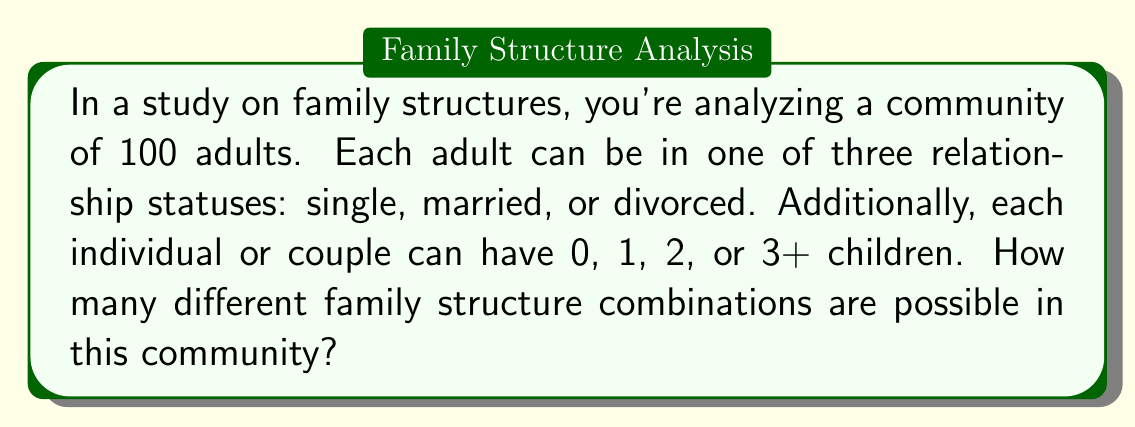Show me your answer to this math problem. Let's approach this step-by-step:

1) First, we need to consider the relationship status options:
   - Single
   - Married
   - Divorced

2) Next, we consider the number of children options:
   - 0 children
   - 1 child
   - 2 children
   - 3+ children

3) For single and divorced individuals, we can directly combine their relationship status with the child options:
   $3 \times 4 = 12$ combinations

4) For married couples, we need to consider that they share the same number of children:
   $1 \times 4 = 4$ combinations

5) Total number of possible family structures for one individual or couple:
   $12 + 4 = 16$ combinations

6) Now, we need to consider how many ways these structures can be distributed among 100 adults. This is a problem of combinations with repetition.

7) The formula for combinations with repetition is:
   $$\binom{n+r-1}{r-1}$$
   where $n$ is the number of types to choose from, and $r$ is the number of items being chosen.

8) In our case, $n = 16$ (number of family structure types) and $r = 100$ (number of adults).

9) Plugging into the formula:
   $$\binom{16+100-1}{16-1} = \binom{115}{15}$$

10) This can be calculated as:
    $$\frac{115!}{15!(115-15)!} = \frac{115!}{15!100!}$$

11) The result of this calculation is a very large number, approximately $2.98 \times 10^{18}$.
Answer: $\binom{115}{15} \approx 2.98 \times 10^{18}$ 